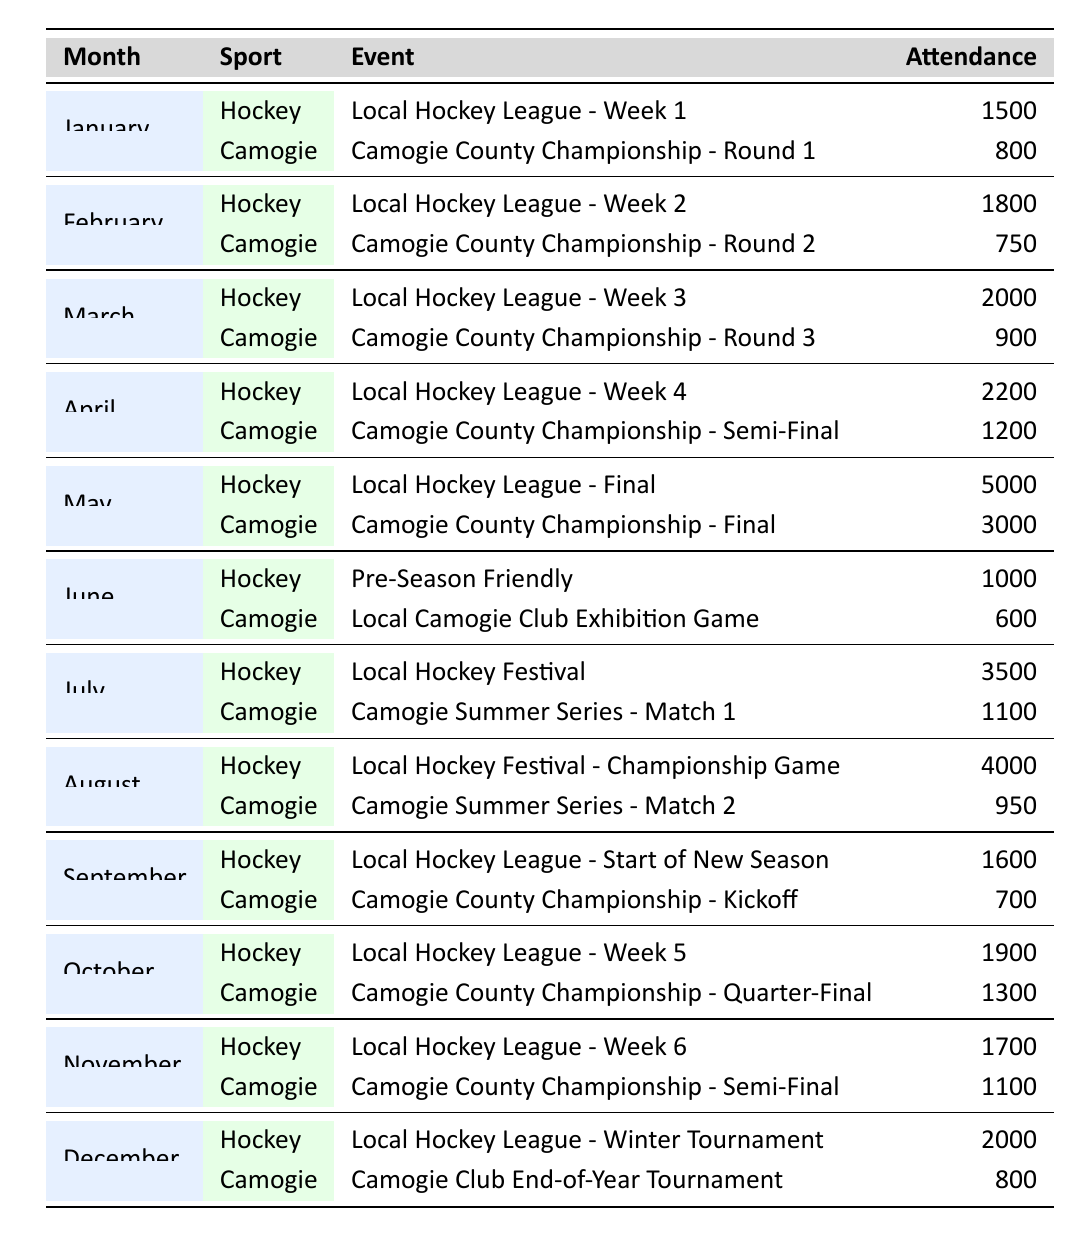What was the highest attendance for a hockey event in 2023? The table shows various hockey events and their attendance figures for each month. By scanning the attendance, the highest figure is found in May, where the attendance was 5000 for the Local Hockey League - Final.
Answer: 5000 What event in March had the highest attendance for camogie? In March, the camogie event listed is the Camogie County Championship - Round 3 with an attendance of 900. Since there is only one camogie event in March, this is the maximum for that month.
Answer: Camogie County Championship - Round 3 What was the attendance difference between the highest and lowest hockey events in July 2023? In July, the Local Hockey Festival had an attendance of 3500, while there was also a hockey event with a lower attendance. The exact sum for comparison is the same event's attendance which remains 3500. Hence, there is no difference to calculate between one figure.
Answer: 0 Was there a camogie event in June 2023? June lists a specific camogie event, which is the Local Camogie Club Exhibition Game with an attendance of 600. This confirms the existence of a camogie event in June.
Answer: Yes What was the average attendance for camogie events in 2023? To find the average attendance for camogie events, add up the attendance figures across all months: 800 (Jan) + 750 (Feb) + 900 (Mar) + 1200 (Apr) + 3000 (May) + 600 (Jun) + 1100 (Jul) + 950 (Aug) + 700 (Sep) + 1300 (Oct) + 1100 (Nov) + 800 (Dec) = 13200. There are 12 events, so average attendance = 13200/12 = 1100.
Answer: 1100 Which month had the lowest overall attendance for local sports events? To determine the month with the lowest overall attendance, sum the attendances for both sports. For example, January attendance is 1500 (hockey) + 800 (camogie) = 2300; repeating this for all months shows January has the lowest overall total of 2300.
Answer: January In which month did the hockey attendance first exceed 2000? By examining the table, we can see that the first hockey event to exceed 2000 attendance is in April (2200 for Local Hockey League - Week 4), so April is the answer.
Answer: April 